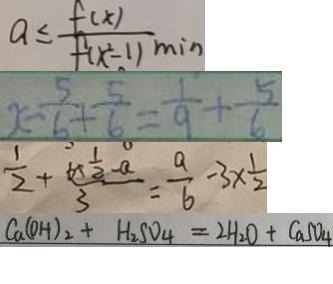<formula> <loc_0><loc_0><loc_500><loc_500>a \leq \frac { f ( x ) } { f ( x ^ { 2 } - 1 ) \min } 
 x - \frac { 5 } { 6 } + \frac { 5 } { 6 } = \frac { 1 } { 9 } + \frac { 5 } { 6 } 
 \frac { 1 } { 2 } + \frac { 6 + \frac { 1 } { 2 } - a } { 3 } = \frac { a } { b } - 3 \times \frac { 1 } { 2 } 
 C a ( O H ) _ { 2 } + H _ { 2 } S O _ { 4 } = 2 H _ { 2 } O + C a S O _ { 4 }</formula> 